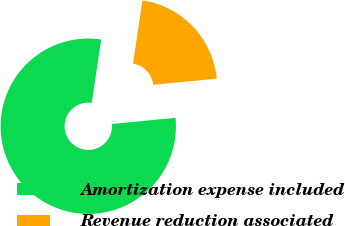Convert chart to OTSL. <chart><loc_0><loc_0><loc_500><loc_500><pie_chart><fcel>Amortization expense included<fcel>Revenue reduction associated<nl><fcel>78.89%<fcel>21.11%<nl></chart> 